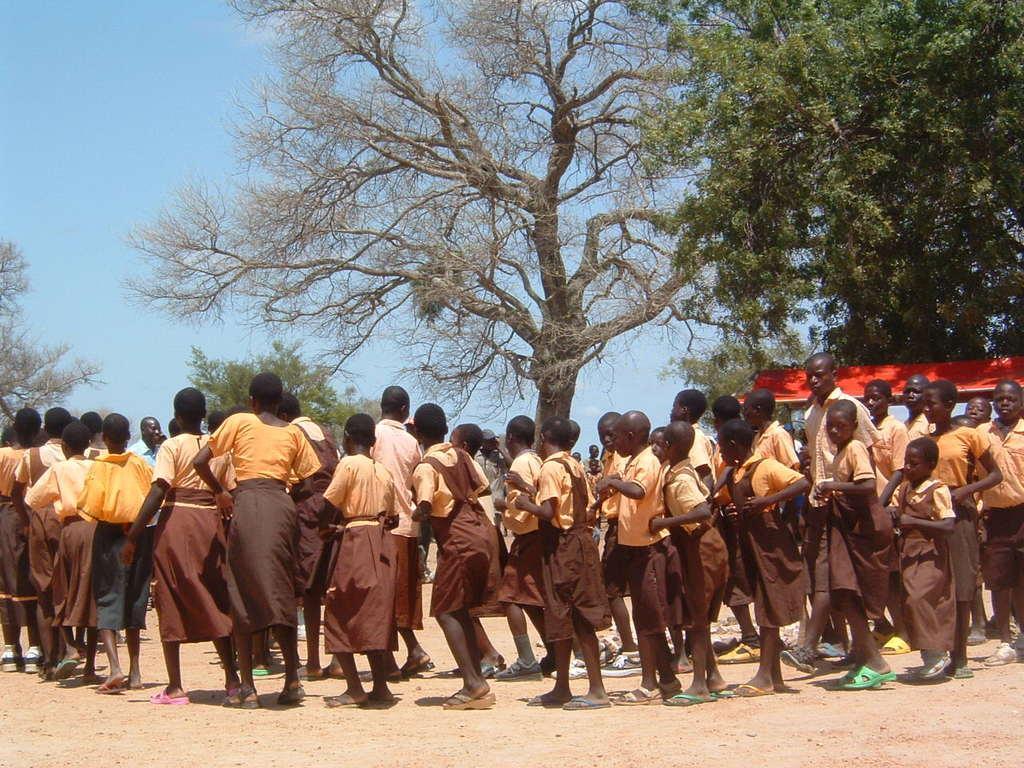Can you describe this image briefly? In this image there are people with uniform and there are on the sand. In the background there are many trees and there is also a red color roof for shelter. Sky is also visible. 